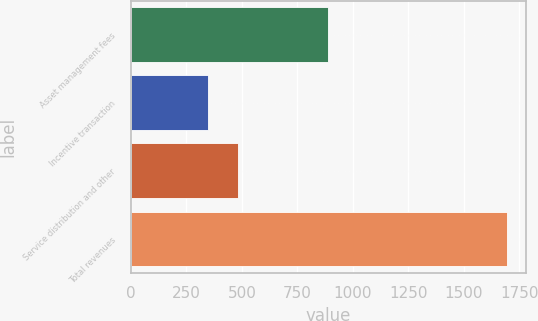<chart> <loc_0><loc_0><loc_500><loc_500><bar_chart><fcel>Asset management fees<fcel>Incentive transaction<fcel>Service distribution and other<fcel>Total revenues<nl><fcel>886<fcel>345<fcel>480.1<fcel>1696<nl></chart> 